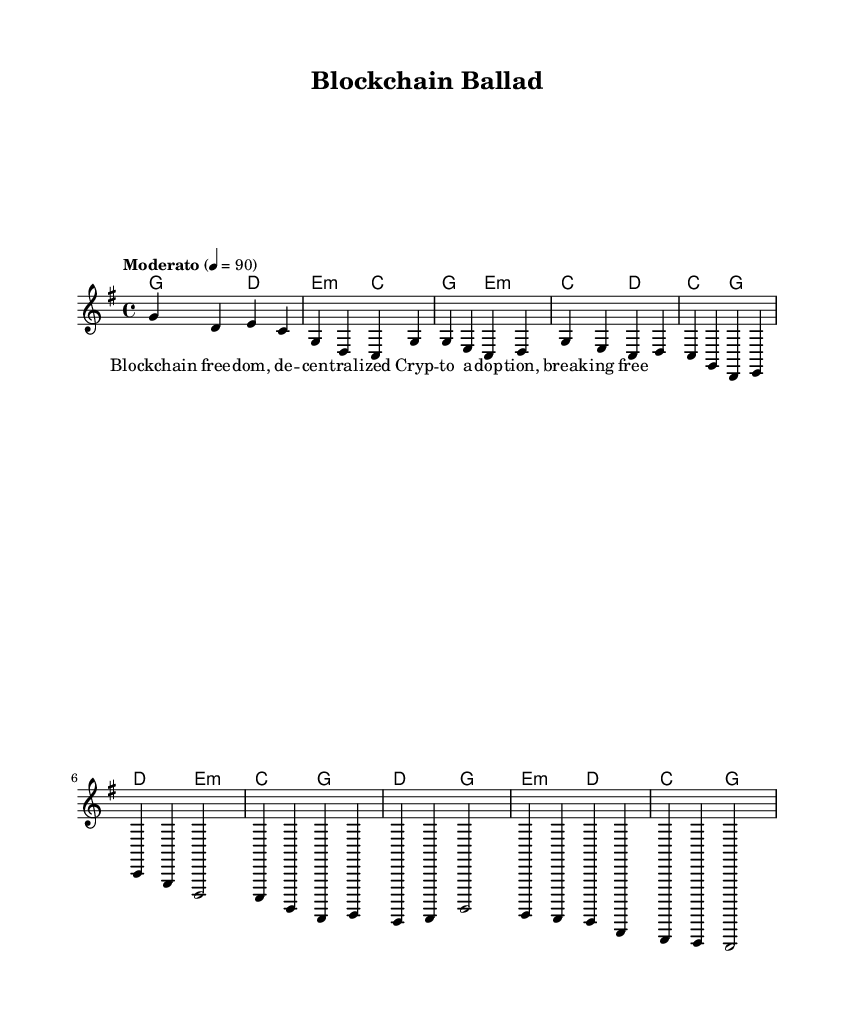What is the key signature of this music? The key signature shown is G major, indicated by one sharp (F#) at the beginning of the staff.
Answer: G major What is the time signature of the piece? The time signature is 4/4, which is indicated at the beginning of the score and shows that there are four beats per measure.
Answer: 4/4 What is the tempo marked for this composition? The tempo marking is "Moderato," with a metronome mark of 90 beats per minute, suggesting a moderate pace for the song.
Answer: Moderato, 90 How many measures are in the Chorus section? The Chorus consists of four measures, as noted by the sequence of chords and melody lines that fit within those four bars.
Answer: 4 What is the harmonic progression for the Intro? The harmonic progression in the Intro is G to D, followed by E minor to C, showing a clear movement through these chords.
Answer: G, D, E minor, C What themes do the lyrics of this song suggest? The lyrics hint at themes of financial freedom and decentralization, explicitly referencing "Blockchain" and "crypto adoption," linking to the modern folk movement's emphasis on such topics.
Answer: Financial freedom, decentralization What kind of musical form does this piece follow? The piece follows a verse-chorus structure, typical in song formats, as evidenced by the separate sections indicated in the music notation.
Answer: Verse-chorus 